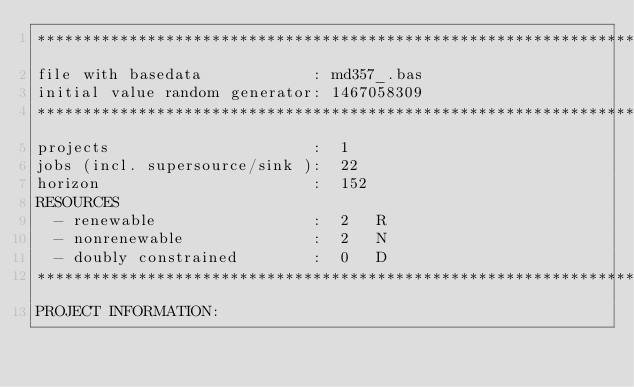<code> <loc_0><loc_0><loc_500><loc_500><_ObjectiveC_>************************************************************************
file with basedata            : md357_.bas
initial value random generator: 1467058309
************************************************************************
projects                      :  1
jobs (incl. supersource/sink ):  22
horizon                       :  152
RESOURCES
  - renewable                 :  2   R
  - nonrenewable              :  2   N
  - doubly constrained        :  0   D
************************************************************************
PROJECT INFORMATION:</code> 